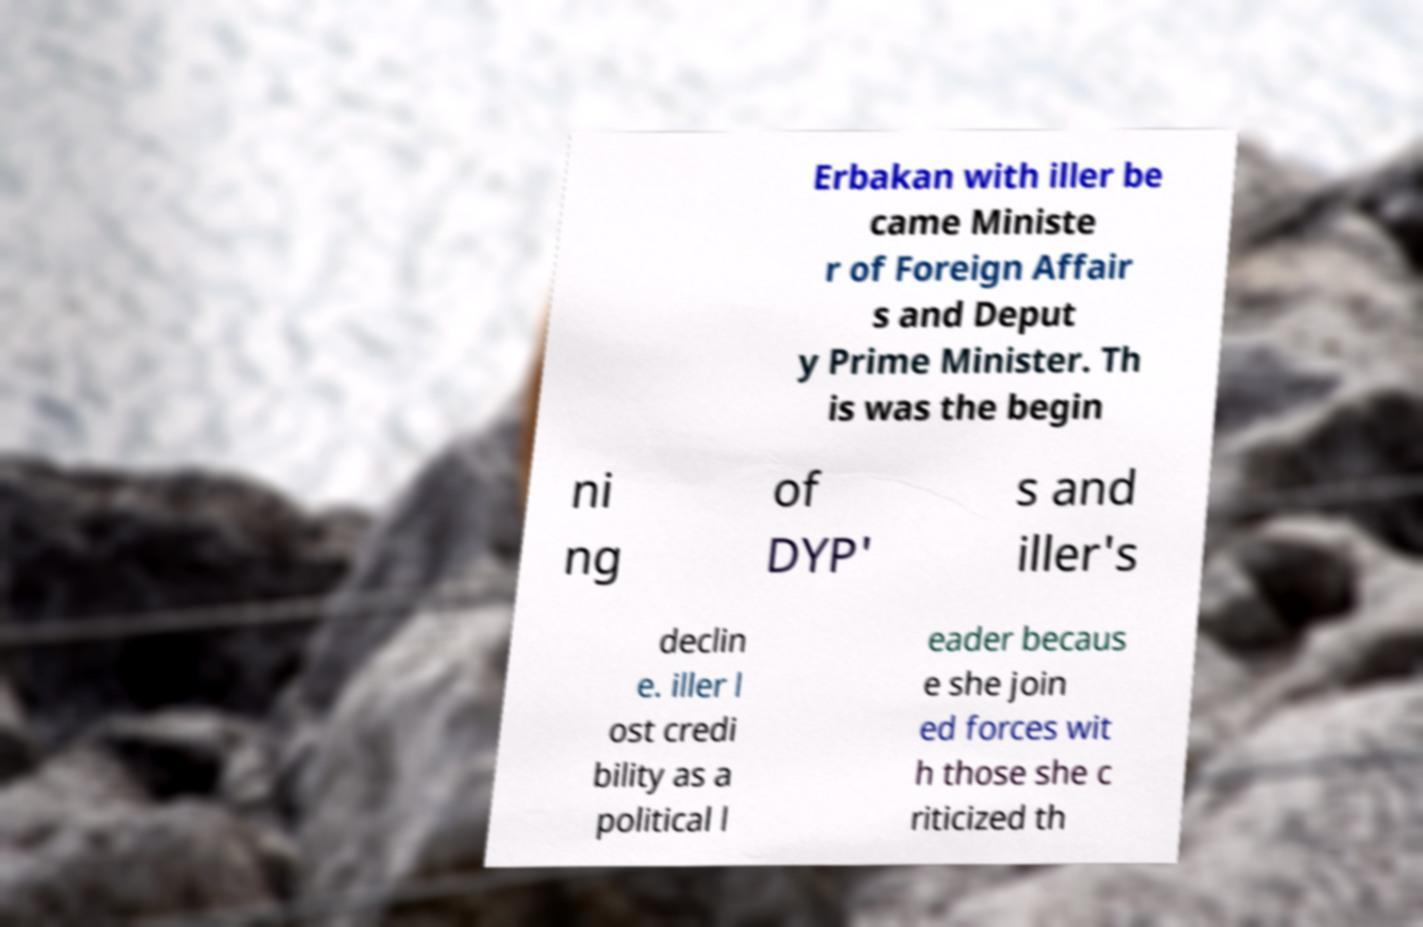Can you read and provide the text displayed in the image?This photo seems to have some interesting text. Can you extract and type it out for me? Erbakan with iller be came Ministe r of Foreign Affair s and Deput y Prime Minister. Th is was the begin ni ng of DYP' s and iller's declin e. iller l ost credi bility as a political l eader becaus e she join ed forces wit h those she c riticized th 